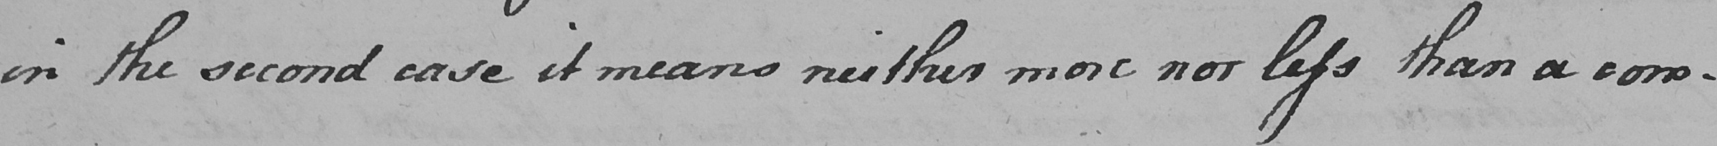Can you tell me what this handwritten text says? in the second case it means neither more nor less than a com- 